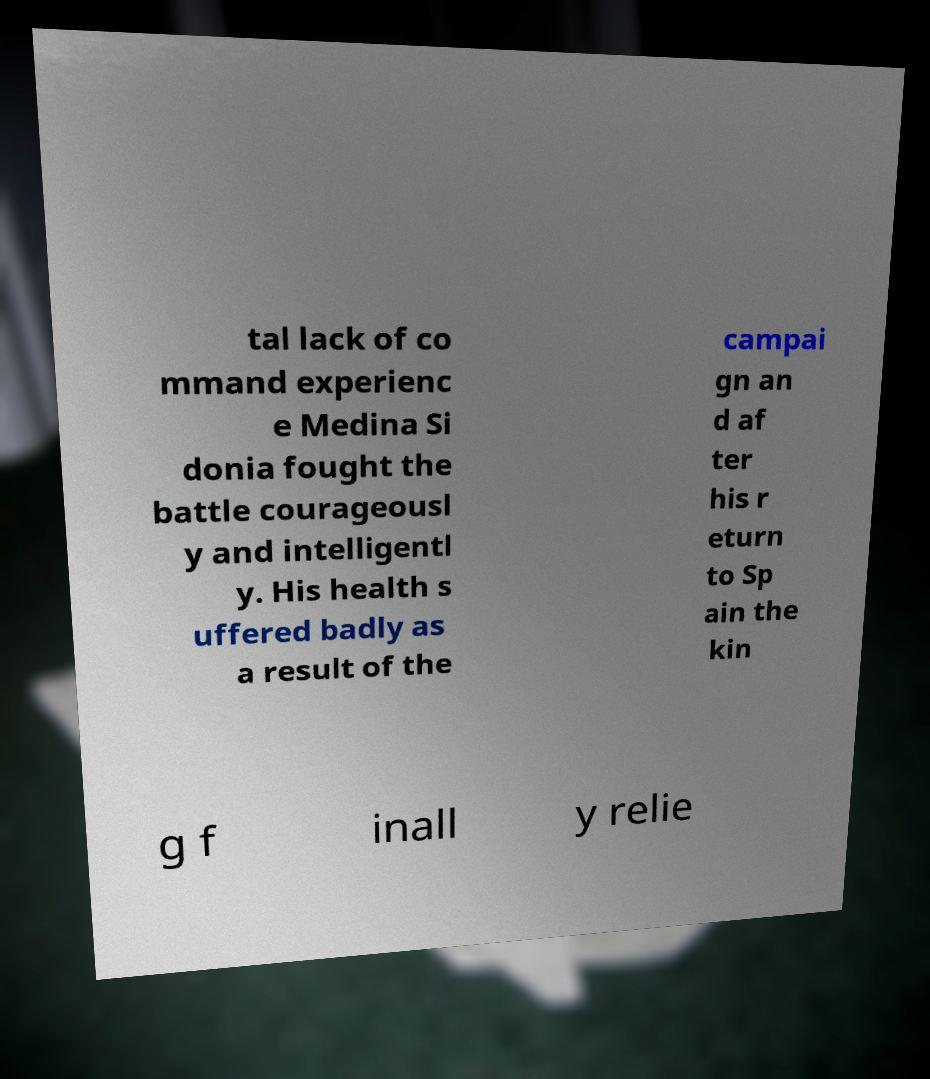For documentation purposes, I need the text within this image transcribed. Could you provide that? tal lack of co mmand experienc e Medina Si donia fought the battle courageousl y and intelligentl y. His health s uffered badly as a result of the campai gn an d af ter his r eturn to Sp ain the kin g f inall y relie 